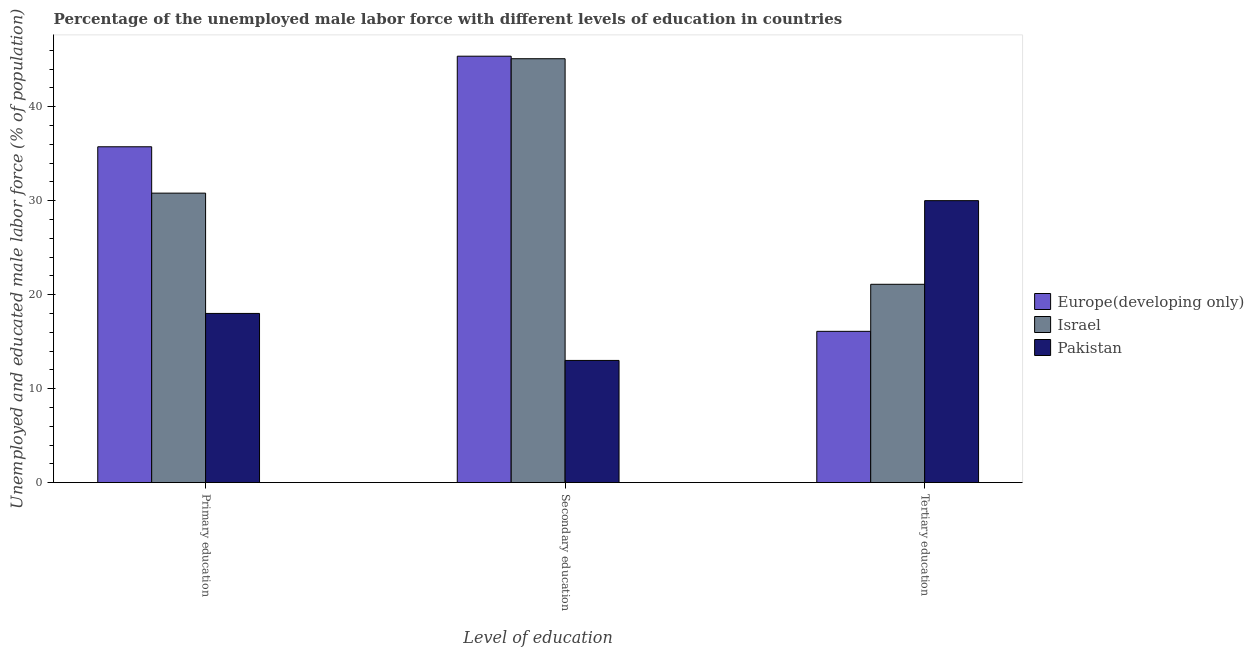How many different coloured bars are there?
Your response must be concise. 3. How many groups of bars are there?
Offer a terse response. 3. How many bars are there on the 1st tick from the left?
Provide a short and direct response. 3. What is the label of the 2nd group of bars from the left?
Keep it short and to the point. Secondary education. What is the percentage of male labor force who received secondary education in Europe(developing only)?
Keep it short and to the point. 45.37. Across all countries, what is the maximum percentage of male labor force who received primary education?
Provide a succinct answer. 35.73. Across all countries, what is the minimum percentage of male labor force who received tertiary education?
Ensure brevity in your answer.  16.1. In which country was the percentage of male labor force who received primary education maximum?
Give a very brief answer. Europe(developing only). In which country was the percentage of male labor force who received tertiary education minimum?
Make the answer very short. Europe(developing only). What is the total percentage of male labor force who received secondary education in the graph?
Offer a very short reply. 103.47. What is the difference between the percentage of male labor force who received primary education in Israel and that in Pakistan?
Provide a succinct answer. 12.8. What is the difference between the percentage of male labor force who received primary education in Europe(developing only) and the percentage of male labor force who received tertiary education in Israel?
Your response must be concise. 14.63. What is the average percentage of male labor force who received primary education per country?
Keep it short and to the point. 28.18. What is the difference between the percentage of male labor force who received tertiary education and percentage of male labor force who received primary education in Israel?
Ensure brevity in your answer.  -9.7. In how many countries, is the percentage of male labor force who received secondary education greater than 34 %?
Give a very brief answer. 2. What is the ratio of the percentage of male labor force who received tertiary education in Pakistan to that in Europe(developing only)?
Offer a terse response. 1.86. Is the percentage of male labor force who received primary education in Pakistan less than that in Europe(developing only)?
Your answer should be very brief. Yes. Is the difference between the percentage of male labor force who received tertiary education in Israel and Europe(developing only) greater than the difference between the percentage of male labor force who received primary education in Israel and Europe(developing only)?
Your answer should be very brief. Yes. What is the difference between the highest and the second highest percentage of male labor force who received tertiary education?
Give a very brief answer. 8.9. What is the difference between the highest and the lowest percentage of male labor force who received tertiary education?
Keep it short and to the point. 13.9. In how many countries, is the percentage of male labor force who received primary education greater than the average percentage of male labor force who received primary education taken over all countries?
Ensure brevity in your answer.  2. Is the sum of the percentage of male labor force who received tertiary education in Pakistan and Israel greater than the maximum percentage of male labor force who received secondary education across all countries?
Provide a short and direct response. Yes. What does the 1st bar from the left in Primary education represents?
Your response must be concise. Europe(developing only). Are all the bars in the graph horizontal?
Ensure brevity in your answer.  No. What is the difference between two consecutive major ticks on the Y-axis?
Give a very brief answer. 10. Where does the legend appear in the graph?
Keep it short and to the point. Center right. How are the legend labels stacked?
Give a very brief answer. Vertical. What is the title of the graph?
Provide a succinct answer. Percentage of the unemployed male labor force with different levels of education in countries. Does "Switzerland" appear as one of the legend labels in the graph?
Give a very brief answer. No. What is the label or title of the X-axis?
Offer a terse response. Level of education. What is the label or title of the Y-axis?
Provide a succinct answer. Unemployed and educated male labor force (% of population). What is the Unemployed and educated male labor force (% of population) of Europe(developing only) in Primary education?
Make the answer very short. 35.73. What is the Unemployed and educated male labor force (% of population) in Israel in Primary education?
Your answer should be compact. 30.8. What is the Unemployed and educated male labor force (% of population) in Europe(developing only) in Secondary education?
Give a very brief answer. 45.37. What is the Unemployed and educated male labor force (% of population) in Israel in Secondary education?
Your response must be concise. 45.1. What is the Unemployed and educated male labor force (% of population) of Pakistan in Secondary education?
Offer a terse response. 13. What is the Unemployed and educated male labor force (% of population) of Europe(developing only) in Tertiary education?
Give a very brief answer. 16.1. What is the Unemployed and educated male labor force (% of population) in Israel in Tertiary education?
Offer a very short reply. 21.1. What is the Unemployed and educated male labor force (% of population) of Pakistan in Tertiary education?
Offer a very short reply. 30. Across all Level of education, what is the maximum Unemployed and educated male labor force (% of population) in Europe(developing only)?
Give a very brief answer. 45.37. Across all Level of education, what is the maximum Unemployed and educated male labor force (% of population) of Israel?
Provide a succinct answer. 45.1. Across all Level of education, what is the maximum Unemployed and educated male labor force (% of population) of Pakistan?
Provide a short and direct response. 30. Across all Level of education, what is the minimum Unemployed and educated male labor force (% of population) of Europe(developing only)?
Offer a terse response. 16.1. Across all Level of education, what is the minimum Unemployed and educated male labor force (% of population) of Israel?
Provide a short and direct response. 21.1. Across all Level of education, what is the minimum Unemployed and educated male labor force (% of population) in Pakistan?
Your answer should be very brief. 13. What is the total Unemployed and educated male labor force (% of population) in Europe(developing only) in the graph?
Your answer should be very brief. 97.2. What is the total Unemployed and educated male labor force (% of population) of Israel in the graph?
Provide a short and direct response. 97. What is the total Unemployed and educated male labor force (% of population) in Pakistan in the graph?
Give a very brief answer. 61. What is the difference between the Unemployed and educated male labor force (% of population) of Europe(developing only) in Primary education and that in Secondary education?
Provide a succinct answer. -9.64. What is the difference between the Unemployed and educated male labor force (% of population) in Israel in Primary education and that in Secondary education?
Your response must be concise. -14.3. What is the difference between the Unemployed and educated male labor force (% of population) of Pakistan in Primary education and that in Secondary education?
Your response must be concise. 5. What is the difference between the Unemployed and educated male labor force (% of population) in Europe(developing only) in Primary education and that in Tertiary education?
Make the answer very short. 19.64. What is the difference between the Unemployed and educated male labor force (% of population) of Israel in Primary education and that in Tertiary education?
Offer a very short reply. 9.7. What is the difference between the Unemployed and educated male labor force (% of population) in Europe(developing only) in Secondary education and that in Tertiary education?
Provide a succinct answer. 29.27. What is the difference between the Unemployed and educated male labor force (% of population) of Pakistan in Secondary education and that in Tertiary education?
Ensure brevity in your answer.  -17. What is the difference between the Unemployed and educated male labor force (% of population) in Europe(developing only) in Primary education and the Unemployed and educated male labor force (% of population) in Israel in Secondary education?
Your answer should be very brief. -9.37. What is the difference between the Unemployed and educated male labor force (% of population) in Europe(developing only) in Primary education and the Unemployed and educated male labor force (% of population) in Pakistan in Secondary education?
Give a very brief answer. 22.73. What is the difference between the Unemployed and educated male labor force (% of population) in Europe(developing only) in Primary education and the Unemployed and educated male labor force (% of population) in Israel in Tertiary education?
Ensure brevity in your answer.  14.63. What is the difference between the Unemployed and educated male labor force (% of population) in Europe(developing only) in Primary education and the Unemployed and educated male labor force (% of population) in Pakistan in Tertiary education?
Make the answer very short. 5.73. What is the difference between the Unemployed and educated male labor force (% of population) of Israel in Primary education and the Unemployed and educated male labor force (% of population) of Pakistan in Tertiary education?
Provide a succinct answer. 0.8. What is the difference between the Unemployed and educated male labor force (% of population) of Europe(developing only) in Secondary education and the Unemployed and educated male labor force (% of population) of Israel in Tertiary education?
Offer a terse response. 24.27. What is the difference between the Unemployed and educated male labor force (% of population) in Europe(developing only) in Secondary education and the Unemployed and educated male labor force (% of population) in Pakistan in Tertiary education?
Give a very brief answer. 15.37. What is the average Unemployed and educated male labor force (% of population) of Europe(developing only) per Level of education?
Provide a short and direct response. 32.4. What is the average Unemployed and educated male labor force (% of population) in Israel per Level of education?
Offer a very short reply. 32.33. What is the average Unemployed and educated male labor force (% of population) of Pakistan per Level of education?
Make the answer very short. 20.33. What is the difference between the Unemployed and educated male labor force (% of population) of Europe(developing only) and Unemployed and educated male labor force (% of population) of Israel in Primary education?
Provide a succinct answer. 4.93. What is the difference between the Unemployed and educated male labor force (% of population) in Europe(developing only) and Unemployed and educated male labor force (% of population) in Pakistan in Primary education?
Offer a very short reply. 17.73. What is the difference between the Unemployed and educated male labor force (% of population) in Israel and Unemployed and educated male labor force (% of population) in Pakistan in Primary education?
Your response must be concise. 12.8. What is the difference between the Unemployed and educated male labor force (% of population) in Europe(developing only) and Unemployed and educated male labor force (% of population) in Israel in Secondary education?
Make the answer very short. 0.27. What is the difference between the Unemployed and educated male labor force (% of population) in Europe(developing only) and Unemployed and educated male labor force (% of population) in Pakistan in Secondary education?
Your response must be concise. 32.37. What is the difference between the Unemployed and educated male labor force (% of population) in Israel and Unemployed and educated male labor force (% of population) in Pakistan in Secondary education?
Your answer should be compact. 32.1. What is the difference between the Unemployed and educated male labor force (% of population) of Europe(developing only) and Unemployed and educated male labor force (% of population) of Israel in Tertiary education?
Your answer should be compact. -5. What is the difference between the Unemployed and educated male labor force (% of population) in Europe(developing only) and Unemployed and educated male labor force (% of population) in Pakistan in Tertiary education?
Keep it short and to the point. -13.9. What is the ratio of the Unemployed and educated male labor force (% of population) in Europe(developing only) in Primary education to that in Secondary education?
Provide a succinct answer. 0.79. What is the ratio of the Unemployed and educated male labor force (% of population) of Israel in Primary education to that in Secondary education?
Your answer should be very brief. 0.68. What is the ratio of the Unemployed and educated male labor force (% of population) in Pakistan in Primary education to that in Secondary education?
Offer a terse response. 1.38. What is the ratio of the Unemployed and educated male labor force (% of population) in Europe(developing only) in Primary education to that in Tertiary education?
Ensure brevity in your answer.  2.22. What is the ratio of the Unemployed and educated male labor force (% of population) in Israel in Primary education to that in Tertiary education?
Keep it short and to the point. 1.46. What is the ratio of the Unemployed and educated male labor force (% of population) in Pakistan in Primary education to that in Tertiary education?
Make the answer very short. 0.6. What is the ratio of the Unemployed and educated male labor force (% of population) in Europe(developing only) in Secondary education to that in Tertiary education?
Your answer should be compact. 2.82. What is the ratio of the Unemployed and educated male labor force (% of population) in Israel in Secondary education to that in Tertiary education?
Your response must be concise. 2.14. What is the ratio of the Unemployed and educated male labor force (% of population) of Pakistan in Secondary education to that in Tertiary education?
Offer a terse response. 0.43. What is the difference between the highest and the second highest Unemployed and educated male labor force (% of population) in Europe(developing only)?
Offer a terse response. 9.64. What is the difference between the highest and the second highest Unemployed and educated male labor force (% of population) in Israel?
Offer a terse response. 14.3. What is the difference between the highest and the lowest Unemployed and educated male labor force (% of population) of Europe(developing only)?
Make the answer very short. 29.27. 